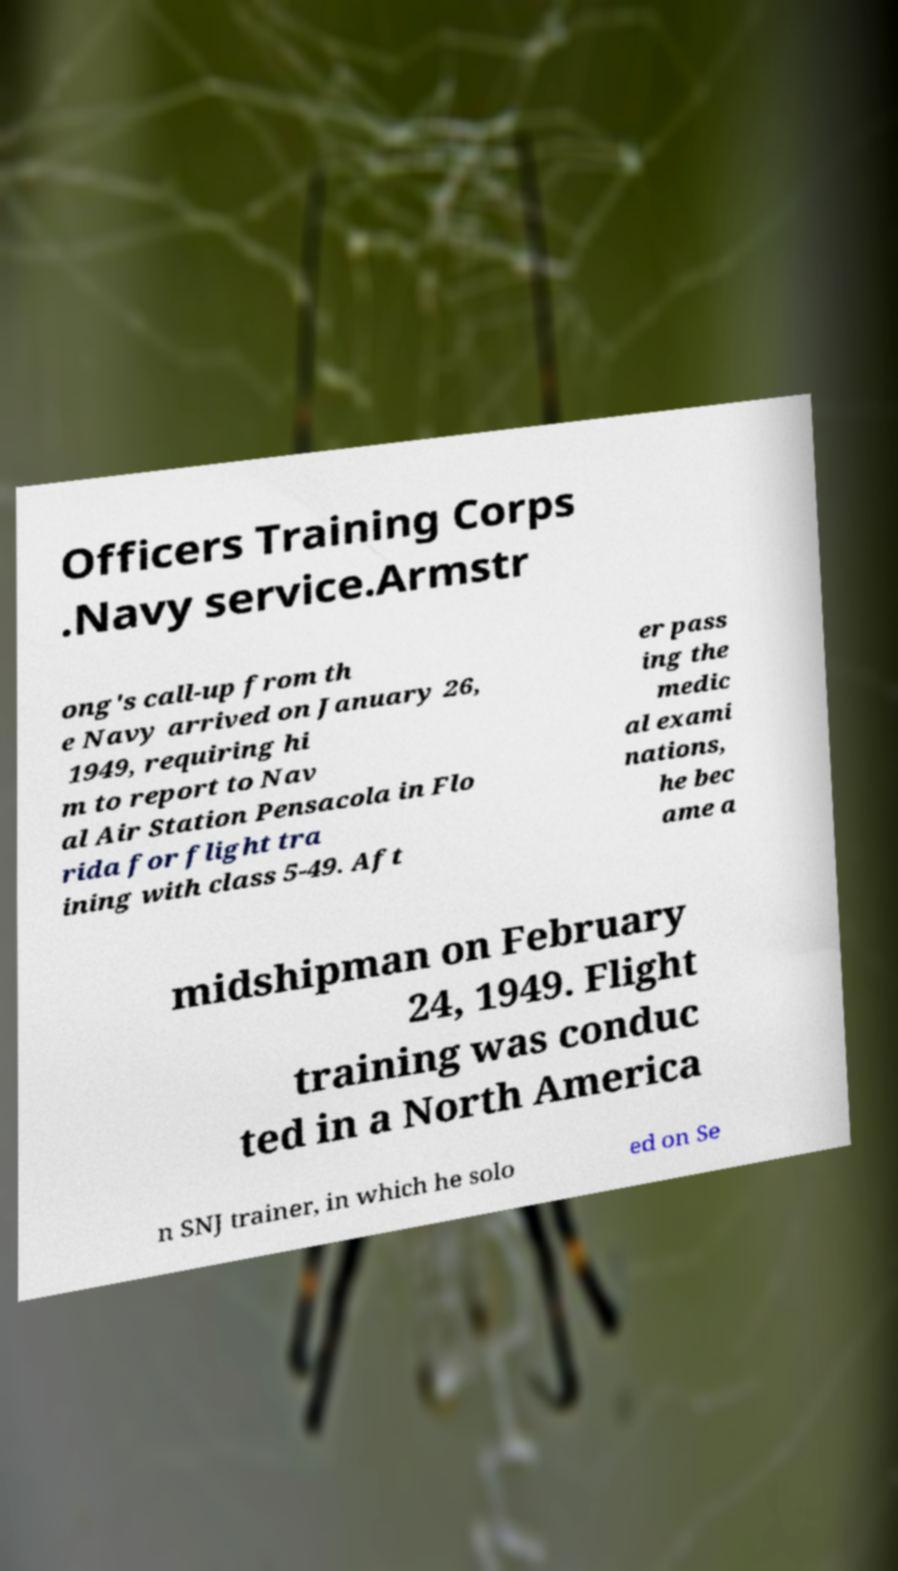Could you assist in decoding the text presented in this image and type it out clearly? Officers Training Corps .Navy service.Armstr ong's call-up from th e Navy arrived on January 26, 1949, requiring hi m to report to Nav al Air Station Pensacola in Flo rida for flight tra ining with class 5-49. Aft er pass ing the medic al exami nations, he bec ame a midshipman on February 24, 1949. Flight training was conduc ted in a North America n SNJ trainer, in which he solo ed on Se 